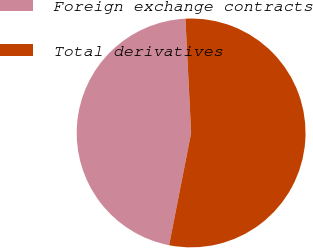Convert chart. <chart><loc_0><loc_0><loc_500><loc_500><pie_chart><fcel>Foreign exchange contracts<fcel>Total derivatives<nl><fcel>46.13%<fcel>53.87%<nl></chart> 